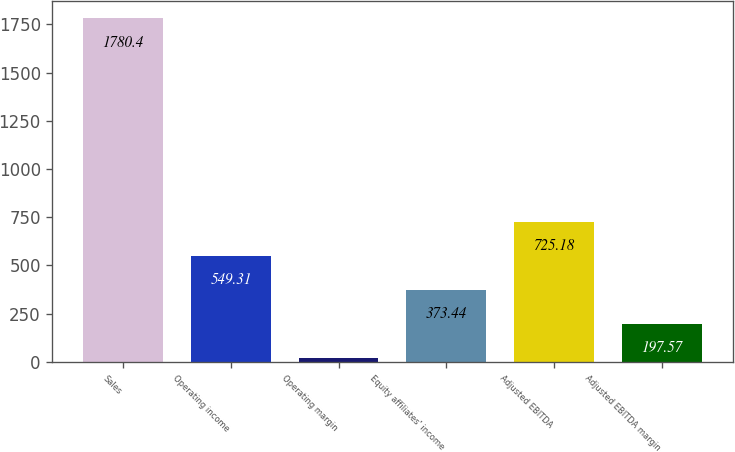<chart> <loc_0><loc_0><loc_500><loc_500><bar_chart><fcel>Sales<fcel>Operating income<fcel>Operating margin<fcel>Equity affiliates' income<fcel>Adjusted EBITDA<fcel>Adjusted EBITDA margin<nl><fcel>1780.4<fcel>549.31<fcel>21.7<fcel>373.44<fcel>725.18<fcel>197.57<nl></chart> 